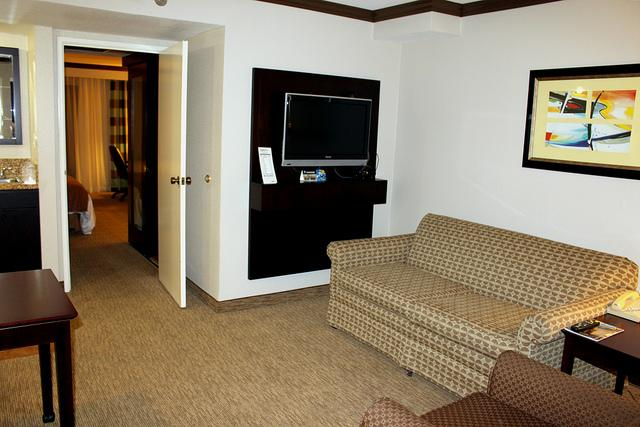Which country is famous for paintings?

Choices:
A) france
B) rome italy
C) poland
D) canada rome italy 